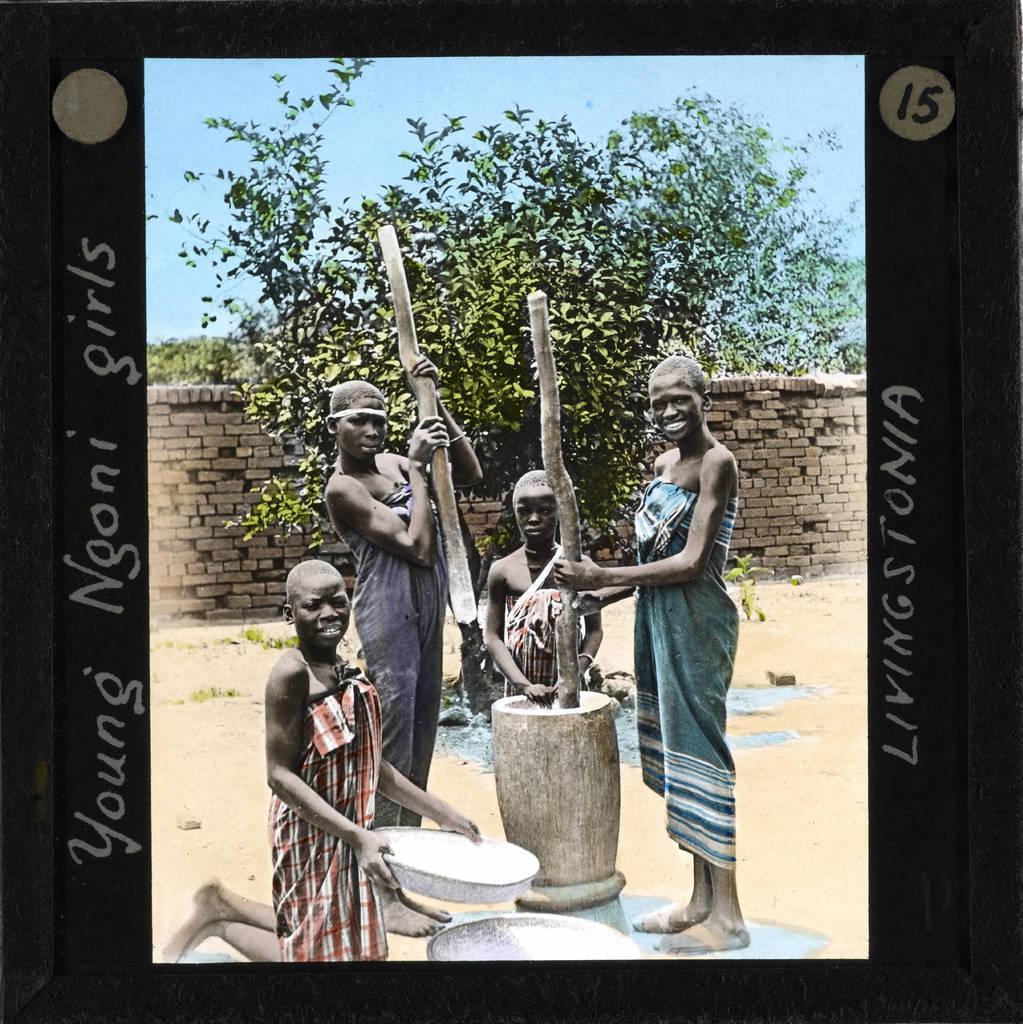Can you describe this image briefly? In the foreground of this image, there is a frame and in the frame, there are four persons, three are standing and one woman is kneeling down on the ground. On the bottom, there are two tubs. In the middle, there is a wooden object, two wooden poles holding by women. In the background, there is a tree, wall and the sky. 